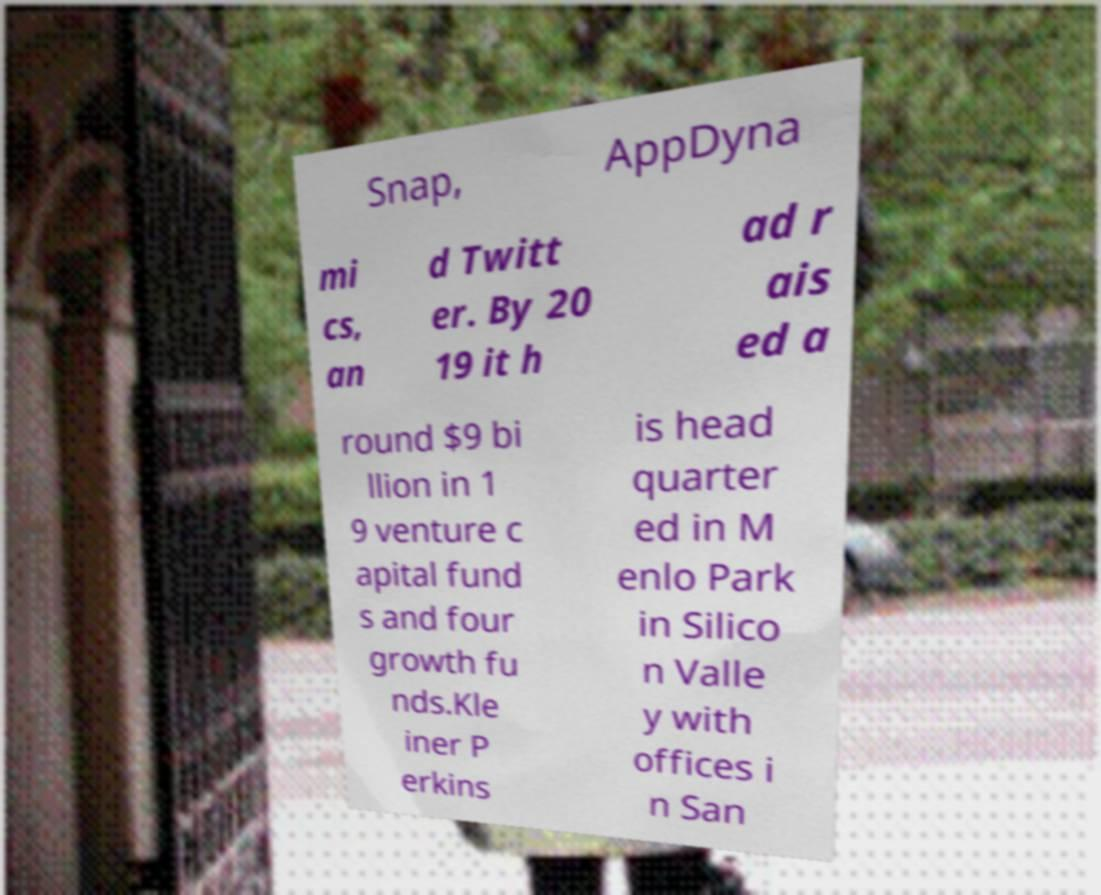What messages or text are displayed in this image? I need them in a readable, typed format. Snap, AppDyna mi cs, an d Twitt er. By 20 19 it h ad r ais ed a round $9 bi llion in 1 9 venture c apital fund s and four growth fu nds.Kle iner P erkins is head quarter ed in M enlo Park in Silico n Valle y with offices i n San 